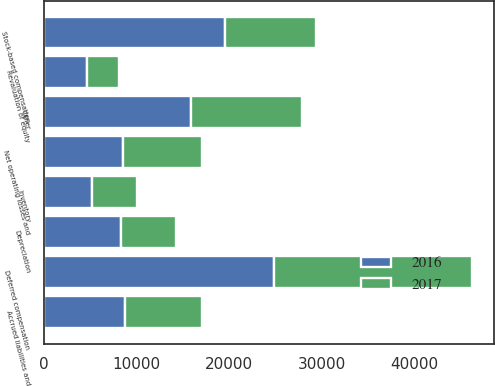Convert chart to OTSL. <chart><loc_0><loc_0><loc_500><loc_500><stacked_bar_chart><ecel><fcel>Net operating losses and<fcel>Depreciation<fcel>Stock-based compensation<fcel>Deferred compensation<fcel>Revaluation of equity<fcel>Inventory<fcel>Accrued liabilities and<fcel>Other<nl><fcel>2017<fcel>8562<fcel>5952<fcel>9815<fcel>21434<fcel>3465<fcel>4864<fcel>8230<fcel>11873<nl><fcel>2016<fcel>8562<fcel>8310<fcel>19609<fcel>24813<fcel>4707<fcel>5235<fcel>8814<fcel>15948<nl></chart> 